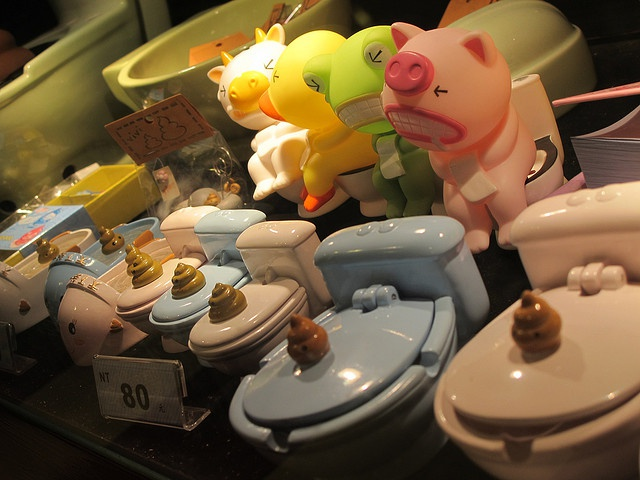Describe the objects in this image and their specific colors. I can see toilet in black, gray, and darkgray tones, toilet in black, tan, and gray tones, toilet in black, gray, maroon, and tan tones, toilet in black, tan, and gray tones, and toilet in black, olive, and khaki tones in this image. 